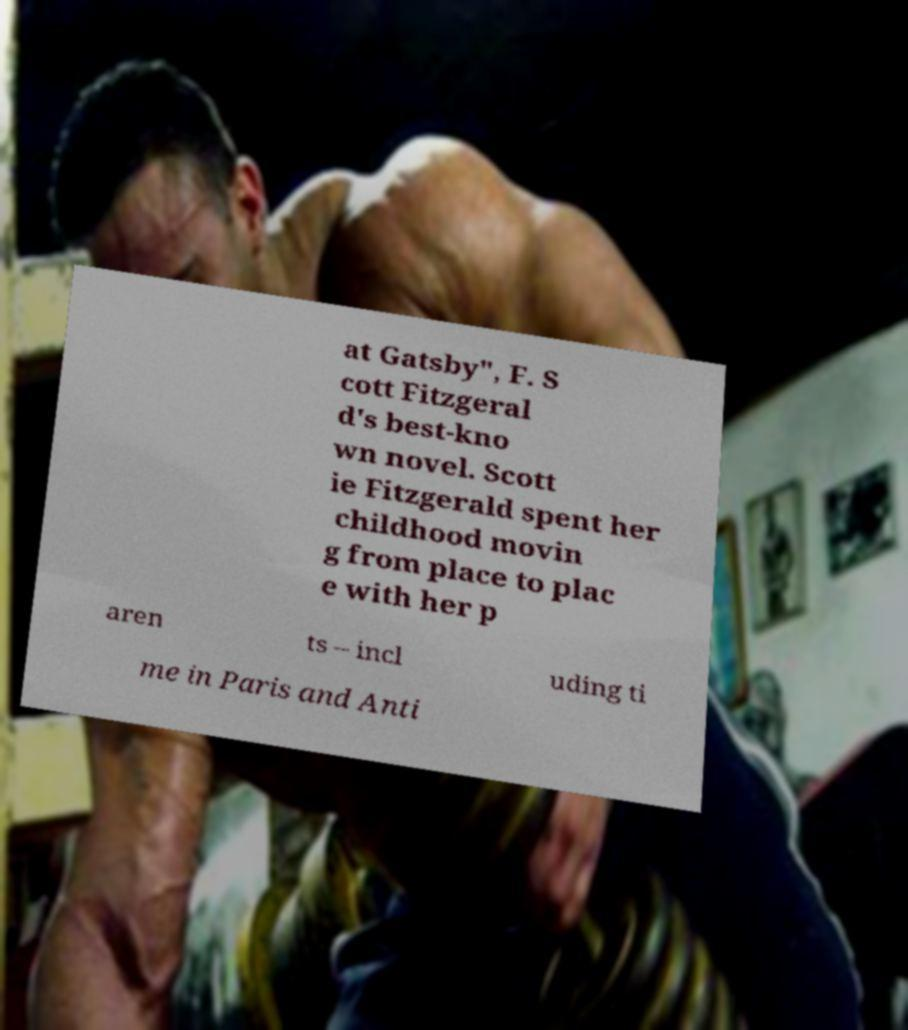Could you assist in decoding the text presented in this image and type it out clearly? at Gatsby", F. S cott Fitzgeral d's best-kno wn novel. Scott ie Fitzgerald spent her childhood movin g from place to plac e with her p aren ts – incl uding ti me in Paris and Anti 